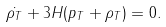Convert formula to latex. <formula><loc_0><loc_0><loc_500><loc_500>\dot { \rho _ { T } } + 3 H ( p _ { T } + \rho _ { T } ) = 0 .</formula> 